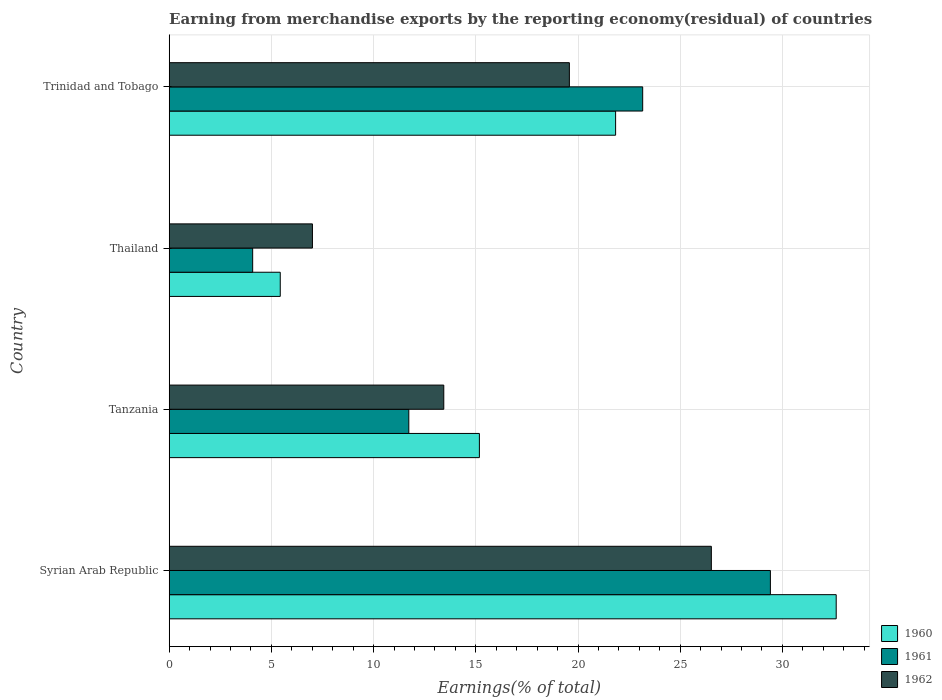How many groups of bars are there?
Make the answer very short. 4. Are the number of bars per tick equal to the number of legend labels?
Give a very brief answer. Yes. How many bars are there on the 4th tick from the top?
Your answer should be very brief. 3. How many bars are there on the 3rd tick from the bottom?
Provide a succinct answer. 3. What is the label of the 4th group of bars from the top?
Offer a very short reply. Syrian Arab Republic. What is the percentage of amount earned from merchandise exports in 1962 in Trinidad and Tobago?
Your answer should be very brief. 19.58. Across all countries, what is the maximum percentage of amount earned from merchandise exports in 1960?
Make the answer very short. 32.63. Across all countries, what is the minimum percentage of amount earned from merchandise exports in 1962?
Keep it short and to the point. 7.01. In which country was the percentage of amount earned from merchandise exports in 1962 maximum?
Keep it short and to the point. Syrian Arab Republic. In which country was the percentage of amount earned from merchandise exports in 1960 minimum?
Your answer should be very brief. Thailand. What is the total percentage of amount earned from merchandise exports in 1960 in the graph?
Make the answer very short. 75.08. What is the difference between the percentage of amount earned from merchandise exports in 1961 in Tanzania and that in Thailand?
Provide a succinct answer. 7.64. What is the difference between the percentage of amount earned from merchandise exports in 1960 in Thailand and the percentage of amount earned from merchandise exports in 1961 in Trinidad and Tobago?
Give a very brief answer. -17.73. What is the average percentage of amount earned from merchandise exports in 1960 per country?
Keep it short and to the point. 18.77. What is the difference between the percentage of amount earned from merchandise exports in 1961 and percentage of amount earned from merchandise exports in 1962 in Thailand?
Give a very brief answer. -2.92. What is the ratio of the percentage of amount earned from merchandise exports in 1960 in Syrian Arab Republic to that in Tanzania?
Your answer should be very brief. 2.15. Is the difference between the percentage of amount earned from merchandise exports in 1961 in Tanzania and Thailand greater than the difference between the percentage of amount earned from merchandise exports in 1962 in Tanzania and Thailand?
Offer a terse response. Yes. What is the difference between the highest and the second highest percentage of amount earned from merchandise exports in 1961?
Your response must be concise. 6.25. What is the difference between the highest and the lowest percentage of amount earned from merchandise exports in 1960?
Your answer should be very brief. 27.2. In how many countries, is the percentage of amount earned from merchandise exports in 1961 greater than the average percentage of amount earned from merchandise exports in 1961 taken over all countries?
Your answer should be compact. 2. Is the sum of the percentage of amount earned from merchandise exports in 1962 in Thailand and Trinidad and Tobago greater than the maximum percentage of amount earned from merchandise exports in 1961 across all countries?
Offer a terse response. No. Is it the case that in every country, the sum of the percentage of amount earned from merchandise exports in 1960 and percentage of amount earned from merchandise exports in 1962 is greater than the percentage of amount earned from merchandise exports in 1961?
Keep it short and to the point. Yes. How many bars are there?
Your answer should be compact. 12. Are all the bars in the graph horizontal?
Make the answer very short. Yes. Does the graph contain any zero values?
Offer a terse response. No. Does the graph contain grids?
Offer a very short reply. Yes. How many legend labels are there?
Offer a very short reply. 3. How are the legend labels stacked?
Offer a very short reply. Vertical. What is the title of the graph?
Your answer should be very brief. Earning from merchandise exports by the reporting economy(residual) of countries. What is the label or title of the X-axis?
Give a very brief answer. Earnings(% of total). What is the label or title of the Y-axis?
Ensure brevity in your answer.  Country. What is the Earnings(% of total) in 1960 in Syrian Arab Republic?
Provide a succinct answer. 32.63. What is the Earnings(% of total) in 1961 in Syrian Arab Republic?
Provide a succinct answer. 29.41. What is the Earnings(% of total) in 1962 in Syrian Arab Republic?
Make the answer very short. 26.52. What is the Earnings(% of total) of 1960 in Tanzania?
Make the answer very short. 15.18. What is the Earnings(% of total) in 1961 in Tanzania?
Offer a very short reply. 11.72. What is the Earnings(% of total) of 1962 in Tanzania?
Your answer should be very brief. 13.43. What is the Earnings(% of total) in 1960 in Thailand?
Ensure brevity in your answer.  5.43. What is the Earnings(% of total) of 1961 in Thailand?
Give a very brief answer. 4.08. What is the Earnings(% of total) in 1962 in Thailand?
Keep it short and to the point. 7.01. What is the Earnings(% of total) in 1960 in Trinidad and Tobago?
Provide a succinct answer. 21.84. What is the Earnings(% of total) of 1961 in Trinidad and Tobago?
Provide a succinct answer. 23.16. What is the Earnings(% of total) of 1962 in Trinidad and Tobago?
Ensure brevity in your answer.  19.58. Across all countries, what is the maximum Earnings(% of total) of 1960?
Make the answer very short. 32.63. Across all countries, what is the maximum Earnings(% of total) in 1961?
Give a very brief answer. 29.41. Across all countries, what is the maximum Earnings(% of total) of 1962?
Offer a very short reply. 26.52. Across all countries, what is the minimum Earnings(% of total) of 1960?
Provide a short and direct response. 5.43. Across all countries, what is the minimum Earnings(% of total) in 1961?
Give a very brief answer. 4.08. Across all countries, what is the minimum Earnings(% of total) of 1962?
Your response must be concise. 7.01. What is the total Earnings(% of total) of 1960 in the graph?
Offer a terse response. 75.08. What is the total Earnings(% of total) of 1961 in the graph?
Your answer should be compact. 68.38. What is the total Earnings(% of total) of 1962 in the graph?
Offer a very short reply. 66.54. What is the difference between the Earnings(% of total) in 1960 in Syrian Arab Republic and that in Tanzania?
Make the answer very short. 17.46. What is the difference between the Earnings(% of total) of 1961 in Syrian Arab Republic and that in Tanzania?
Your response must be concise. 17.69. What is the difference between the Earnings(% of total) of 1962 in Syrian Arab Republic and that in Tanzania?
Your answer should be compact. 13.09. What is the difference between the Earnings(% of total) in 1960 in Syrian Arab Republic and that in Thailand?
Your answer should be very brief. 27.2. What is the difference between the Earnings(% of total) in 1961 in Syrian Arab Republic and that in Thailand?
Provide a succinct answer. 25.33. What is the difference between the Earnings(% of total) of 1962 in Syrian Arab Republic and that in Thailand?
Make the answer very short. 19.52. What is the difference between the Earnings(% of total) in 1960 in Syrian Arab Republic and that in Trinidad and Tobago?
Give a very brief answer. 10.79. What is the difference between the Earnings(% of total) in 1961 in Syrian Arab Republic and that in Trinidad and Tobago?
Make the answer very short. 6.25. What is the difference between the Earnings(% of total) of 1962 in Syrian Arab Republic and that in Trinidad and Tobago?
Your answer should be compact. 6.95. What is the difference between the Earnings(% of total) in 1960 in Tanzania and that in Thailand?
Your answer should be compact. 9.74. What is the difference between the Earnings(% of total) in 1961 in Tanzania and that in Thailand?
Give a very brief answer. 7.64. What is the difference between the Earnings(% of total) of 1962 in Tanzania and that in Thailand?
Your answer should be very brief. 6.43. What is the difference between the Earnings(% of total) in 1960 in Tanzania and that in Trinidad and Tobago?
Your answer should be compact. -6.66. What is the difference between the Earnings(% of total) of 1961 in Tanzania and that in Trinidad and Tobago?
Provide a succinct answer. -11.44. What is the difference between the Earnings(% of total) of 1962 in Tanzania and that in Trinidad and Tobago?
Provide a succinct answer. -6.14. What is the difference between the Earnings(% of total) in 1960 in Thailand and that in Trinidad and Tobago?
Give a very brief answer. -16.41. What is the difference between the Earnings(% of total) in 1961 in Thailand and that in Trinidad and Tobago?
Provide a succinct answer. -19.08. What is the difference between the Earnings(% of total) in 1962 in Thailand and that in Trinidad and Tobago?
Offer a terse response. -12.57. What is the difference between the Earnings(% of total) in 1960 in Syrian Arab Republic and the Earnings(% of total) in 1961 in Tanzania?
Your answer should be very brief. 20.91. What is the difference between the Earnings(% of total) in 1960 in Syrian Arab Republic and the Earnings(% of total) in 1962 in Tanzania?
Make the answer very short. 19.2. What is the difference between the Earnings(% of total) of 1961 in Syrian Arab Republic and the Earnings(% of total) of 1962 in Tanzania?
Make the answer very short. 15.98. What is the difference between the Earnings(% of total) in 1960 in Syrian Arab Republic and the Earnings(% of total) in 1961 in Thailand?
Offer a terse response. 28.55. What is the difference between the Earnings(% of total) in 1960 in Syrian Arab Republic and the Earnings(% of total) in 1962 in Thailand?
Ensure brevity in your answer.  25.62. What is the difference between the Earnings(% of total) of 1961 in Syrian Arab Republic and the Earnings(% of total) of 1962 in Thailand?
Offer a terse response. 22.4. What is the difference between the Earnings(% of total) of 1960 in Syrian Arab Republic and the Earnings(% of total) of 1961 in Trinidad and Tobago?
Give a very brief answer. 9.47. What is the difference between the Earnings(% of total) of 1960 in Syrian Arab Republic and the Earnings(% of total) of 1962 in Trinidad and Tobago?
Keep it short and to the point. 13.05. What is the difference between the Earnings(% of total) of 1961 in Syrian Arab Republic and the Earnings(% of total) of 1962 in Trinidad and Tobago?
Ensure brevity in your answer.  9.83. What is the difference between the Earnings(% of total) in 1960 in Tanzania and the Earnings(% of total) in 1961 in Thailand?
Offer a very short reply. 11.09. What is the difference between the Earnings(% of total) of 1960 in Tanzania and the Earnings(% of total) of 1962 in Thailand?
Offer a very short reply. 8.17. What is the difference between the Earnings(% of total) in 1961 in Tanzania and the Earnings(% of total) in 1962 in Thailand?
Offer a very short reply. 4.72. What is the difference between the Earnings(% of total) in 1960 in Tanzania and the Earnings(% of total) in 1961 in Trinidad and Tobago?
Ensure brevity in your answer.  -7.99. What is the difference between the Earnings(% of total) of 1960 in Tanzania and the Earnings(% of total) of 1962 in Trinidad and Tobago?
Your answer should be compact. -4.4. What is the difference between the Earnings(% of total) in 1961 in Tanzania and the Earnings(% of total) in 1962 in Trinidad and Tobago?
Your answer should be very brief. -7.86. What is the difference between the Earnings(% of total) in 1960 in Thailand and the Earnings(% of total) in 1961 in Trinidad and Tobago?
Provide a short and direct response. -17.73. What is the difference between the Earnings(% of total) in 1960 in Thailand and the Earnings(% of total) in 1962 in Trinidad and Tobago?
Keep it short and to the point. -14.14. What is the difference between the Earnings(% of total) in 1961 in Thailand and the Earnings(% of total) in 1962 in Trinidad and Tobago?
Your response must be concise. -15.49. What is the average Earnings(% of total) in 1960 per country?
Your answer should be compact. 18.77. What is the average Earnings(% of total) of 1961 per country?
Keep it short and to the point. 17.1. What is the average Earnings(% of total) in 1962 per country?
Ensure brevity in your answer.  16.64. What is the difference between the Earnings(% of total) in 1960 and Earnings(% of total) in 1961 in Syrian Arab Republic?
Your response must be concise. 3.22. What is the difference between the Earnings(% of total) in 1960 and Earnings(% of total) in 1962 in Syrian Arab Republic?
Your response must be concise. 6.11. What is the difference between the Earnings(% of total) of 1961 and Earnings(% of total) of 1962 in Syrian Arab Republic?
Keep it short and to the point. 2.89. What is the difference between the Earnings(% of total) of 1960 and Earnings(% of total) of 1961 in Tanzania?
Keep it short and to the point. 3.45. What is the difference between the Earnings(% of total) of 1960 and Earnings(% of total) of 1962 in Tanzania?
Offer a terse response. 1.74. What is the difference between the Earnings(% of total) in 1961 and Earnings(% of total) in 1962 in Tanzania?
Your response must be concise. -1.71. What is the difference between the Earnings(% of total) of 1960 and Earnings(% of total) of 1961 in Thailand?
Make the answer very short. 1.35. What is the difference between the Earnings(% of total) in 1960 and Earnings(% of total) in 1962 in Thailand?
Give a very brief answer. -1.57. What is the difference between the Earnings(% of total) of 1961 and Earnings(% of total) of 1962 in Thailand?
Give a very brief answer. -2.92. What is the difference between the Earnings(% of total) in 1960 and Earnings(% of total) in 1961 in Trinidad and Tobago?
Give a very brief answer. -1.32. What is the difference between the Earnings(% of total) of 1960 and Earnings(% of total) of 1962 in Trinidad and Tobago?
Keep it short and to the point. 2.26. What is the difference between the Earnings(% of total) of 1961 and Earnings(% of total) of 1962 in Trinidad and Tobago?
Your answer should be very brief. 3.59. What is the ratio of the Earnings(% of total) in 1960 in Syrian Arab Republic to that in Tanzania?
Your answer should be compact. 2.15. What is the ratio of the Earnings(% of total) in 1961 in Syrian Arab Republic to that in Tanzania?
Provide a short and direct response. 2.51. What is the ratio of the Earnings(% of total) of 1962 in Syrian Arab Republic to that in Tanzania?
Provide a succinct answer. 1.97. What is the ratio of the Earnings(% of total) in 1960 in Syrian Arab Republic to that in Thailand?
Keep it short and to the point. 6.01. What is the ratio of the Earnings(% of total) in 1961 in Syrian Arab Republic to that in Thailand?
Ensure brevity in your answer.  7.2. What is the ratio of the Earnings(% of total) of 1962 in Syrian Arab Republic to that in Thailand?
Make the answer very short. 3.79. What is the ratio of the Earnings(% of total) of 1960 in Syrian Arab Republic to that in Trinidad and Tobago?
Keep it short and to the point. 1.49. What is the ratio of the Earnings(% of total) in 1961 in Syrian Arab Republic to that in Trinidad and Tobago?
Make the answer very short. 1.27. What is the ratio of the Earnings(% of total) in 1962 in Syrian Arab Republic to that in Trinidad and Tobago?
Ensure brevity in your answer.  1.35. What is the ratio of the Earnings(% of total) in 1960 in Tanzania to that in Thailand?
Provide a short and direct response. 2.79. What is the ratio of the Earnings(% of total) in 1961 in Tanzania to that in Thailand?
Offer a terse response. 2.87. What is the ratio of the Earnings(% of total) of 1962 in Tanzania to that in Thailand?
Offer a very short reply. 1.92. What is the ratio of the Earnings(% of total) in 1960 in Tanzania to that in Trinidad and Tobago?
Your answer should be compact. 0.69. What is the ratio of the Earnings(% of total) of 1961 in Tanzania to that in Trinidad and Tobago?
Offer a very short reply. 0.51. What is the ratio of the Earnings(% of total) of 1962 in Tanzania to that in Trinidad and Tobago?
Make the answer very short. 0.69. What is the ratio of the Earnings(% of total) in 1960 in Thailand to that in Trinidad and Tobago?
Your response must be concise. 0.25. What is the ratio of the Earnings(% of total) of 1961 in Thailand to that in Trinidad and Tobago?
Your answer should be compact. 0.18. What is the ratio of the Earnings(% of total) in 1962 in Thailand to that in Trinidad and Tobago?
Your response must be concise. 0.36. What is the difference between the highest and the second highest Earnings(% of total) in 1960?
Make the answer very short. 10.79. What is the difference between the highest and the second highest Earnings(% of total) of 1961?
Make the answer very short. 6.25. What is the difference between the highest and the second highest Earnings(% of total) of 1962?
Give a very brief answer. 6.95. What is the difference between the highest and the lowest Earnings(% of total) of 1960?
Keep it short and to the point. 27.2. What is the difference between the highest and the lowest Earnings(% of total) in 1961?
Provide a succinct answer. 25.33. What is the difference between the highest and the lowest Earnings(% of total) of 1962?
Make the answer very short. 19.52. 